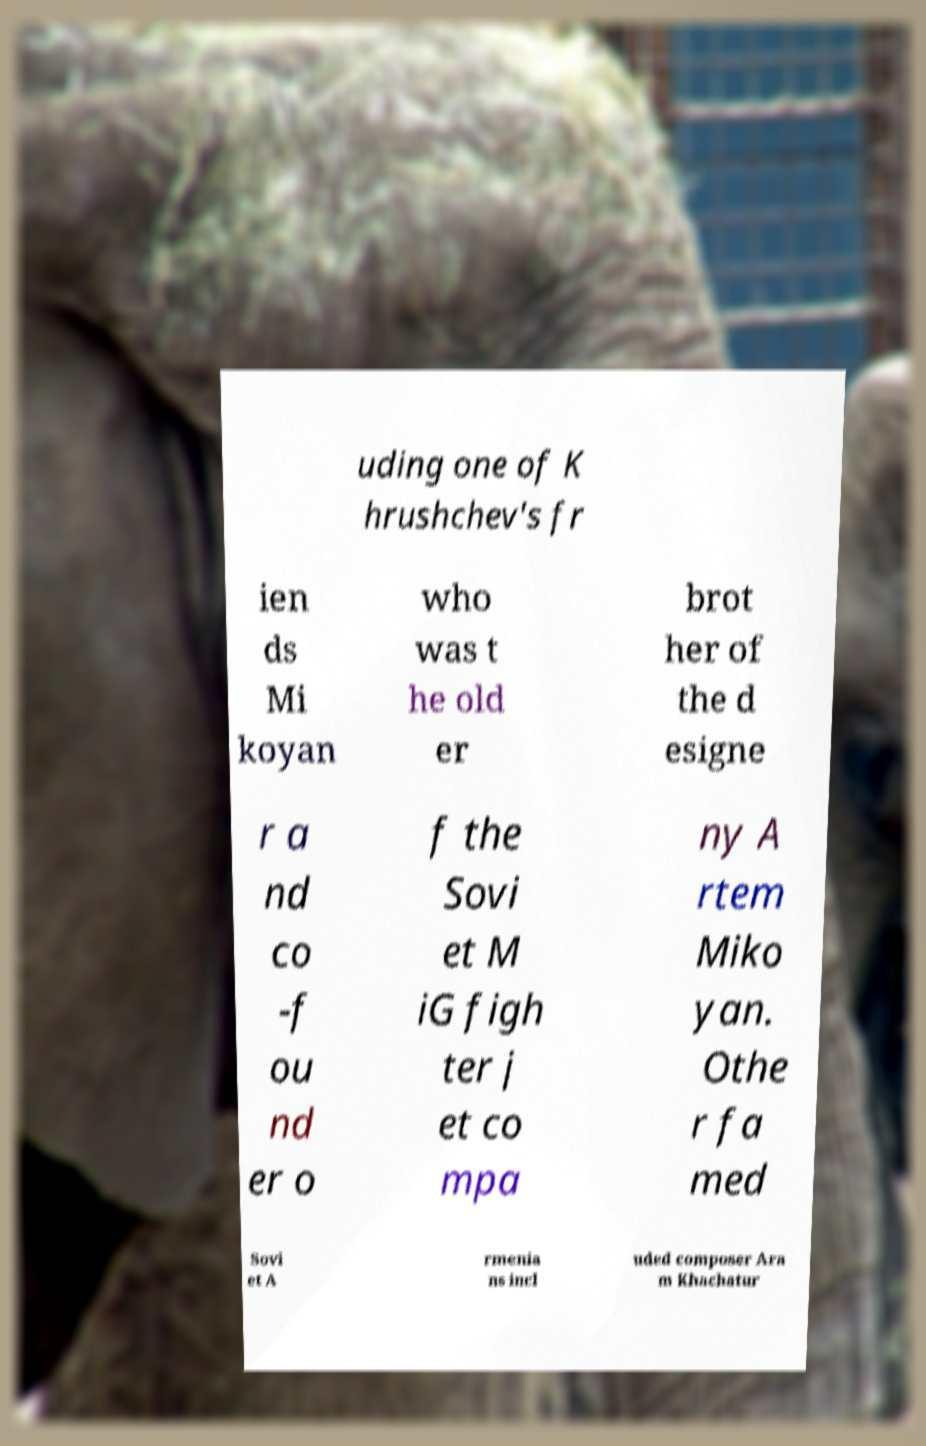Please read and relay the text visible in this image. What does it say? uding one of K hrushchev's fr ien ds Mi koyan who was t he old er brot her of the d esigne r a nd co -f ou nd er o f the Sovi et M iG figh ter j et co mpa ny A rtem Miko yan. Othe r fa med Sovi et A rmenia ns incl uded composer Ara m Khachatur 